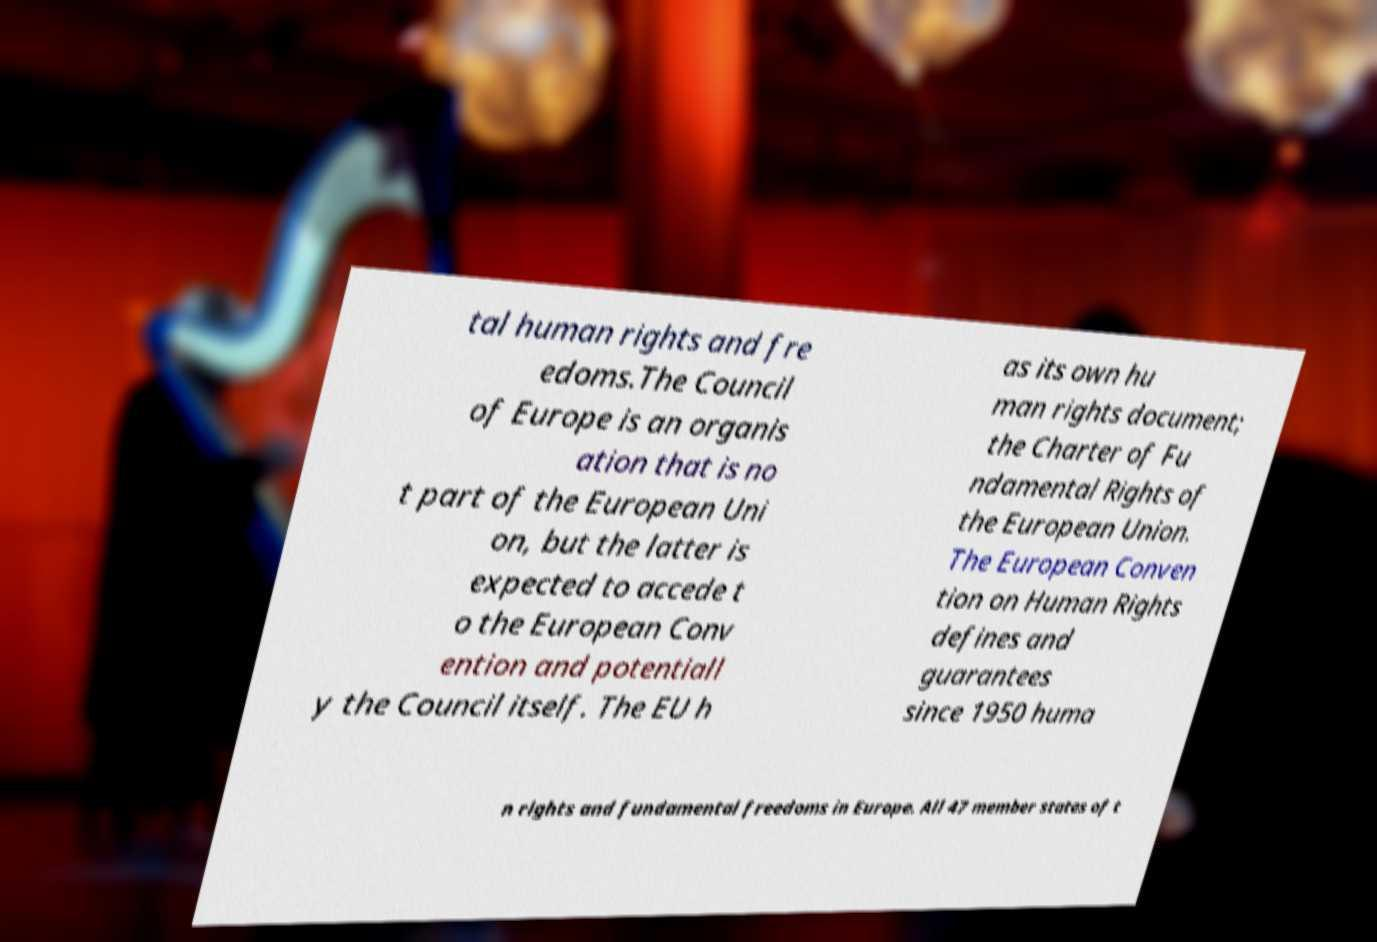Can you read and provide the text displayed in the image?This photo seems to have some interesting text. Can you extract and type it out for me? tal human rights and fre edoms.The Council of Europe is an organis ation that is no t part of the European Uni on, but the latter is expected to accede t o the European Conv ention and potentiall y the Council itself. The EU h as its own hu man rights document; the Charter of Fu ndamental Rights of the European Union. The European Conven tion on Human Rights defines and guarantees since 1950 huma n rights and fundamental freedoms in Europe. All 47 member states of t 